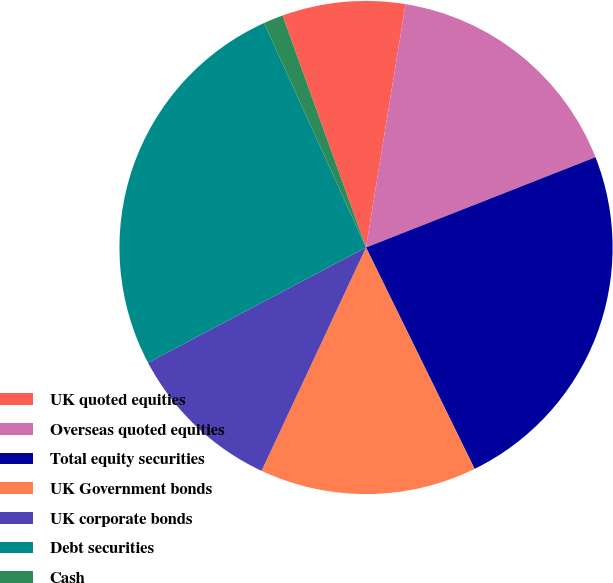Convert chart to OTSL. <chart><loc_0><loc_0><loc_500><loc_500><pie_chart><fcel>UK quoted equities<fcel>Overseas quoted equities<fcel>Total equity securities<fcel>UK Government bonds<fcel>UK corporate bonds<fcel>Debt securities<fcel>Cash<nl><fcel>8.06%<fcel>16.47%<fcel>23.71%<fcel>14.22%<fcel>10.3%<fcel>25.95%<fcel>1.29%<nl></chart> 